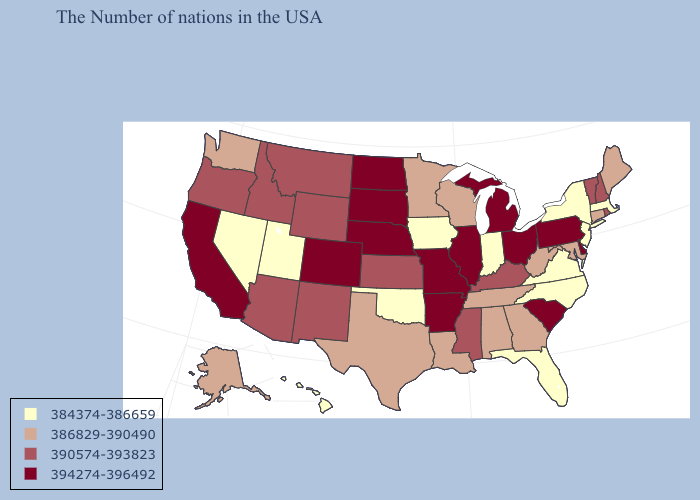What is the value of Connecticut?
Be succinct. 386829-390490. What is the highest value in the USA?
Be succinct. 394274-396492. Does Kansas have the lowest value in the MidWest?
Short answer required. No. What is the lowest value in the Northeast?
Short answer required. 384374-386659. Does Georgia have a higher value than Iowa?
Be succinct. Yes. Which states have the highest value in the USA?
Concise answer only. Delaware, Pennsylvania, South Carolina, Ohio, Michigan, Illinois, Missouri, Arkansas, Nebraska, South Dakota, North Dakota, Colorado, California. Name the states that have a value in the range 390574-393823?
Answer briefly. Rhode Island, New Hampshire, Vermont, Kentucky, Mississippi, Kansas, Wyoming, New Mexico, Montana, Arizona, Idaho, Oregon. Among the states that border North Carolina , which have the lowest value?
Answer briefly. Virginia. What is the highest value in states that border Nevada?
Short answer required. 394274-396492. What is the value of Utah?
Concise answer only. 384374-386659. Which states have the lowest value in the USA?
Concise answer only. Massachusetts, New York, New Jersey, Virginia, North Carolina, Florida, Indiana, Iowa, Oklahoma, Utah, Nevada, Hawaii. Which states hav the highest value in the MidWest?
Give a very brief answer. Ohio, Michigan, Illinois, Missouri, Nebraska, South Dakota, North Dakota. What is the highest value in states that border Nevada?
Answer briefly. 394274-396492. Does the first symbol in the legend represent the smallest category?
Keep it brief. Yes. How many symbols are there in the legend?
Be succinct. 4. 